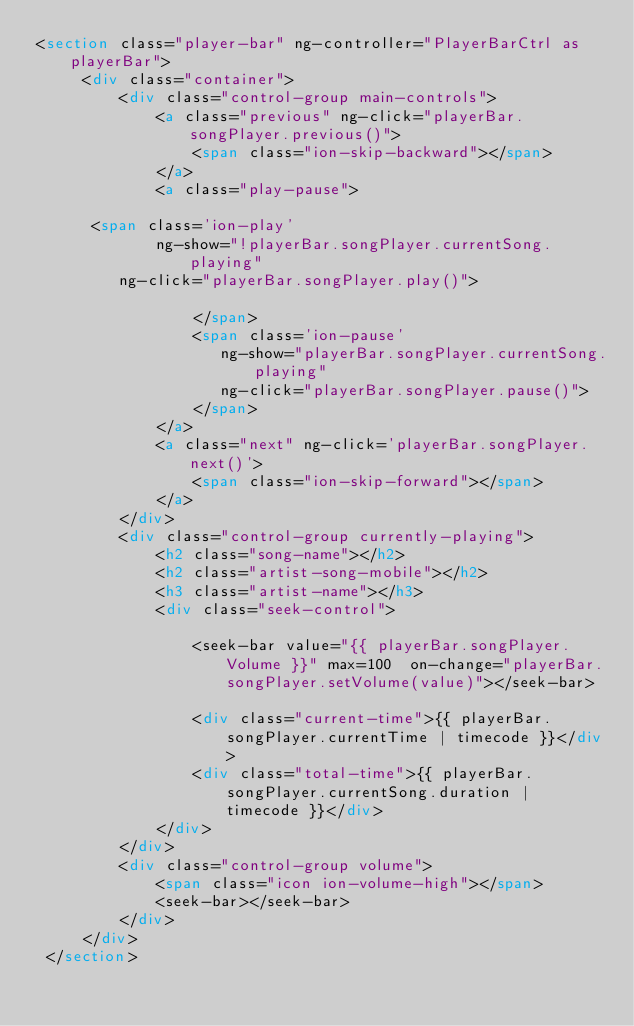<code> <loc_0><loc_0><loc_500><loc_500><_HTML_><section class="player-bar" ng-controller="PlayerBarCtrl as playerBar">
     <div class="container">
         <div class="control-group main-controls">
             <a class="previous" ng-click="playerBar.songPlayer.previous()">
                 <span class="ion-skip-backward"></span>
             </a>
             <a class="play-pause">
                 
      <span class='ion-play'
             ng-show="!playerBar.songPlayer.currentSong.playing"
         ng-click="playerBar.songPlayer.play()">
       
                 </span>
                 <span class='ion-pause'
                    ng-show="playerBar.songPlayer.currentSong.playing"
                    ng-click="playerBar.songPlayer.pause()">
                 </span>
             </a>
             <a class="next" ng-click='playerBar.songPlayer.next()'>
                 <span class="ion-skip-forward"></span>
             </a>
         </div>
         <div class="control-group currently-playing">
             <h2 class="song-name"></h2>
             <h2 class="artist-song-mobile"></h2>
             <h3 class="artist-name"></h3>
             <div class="seek-control">
               
                 <seek-bar value="{{ playerBar.songPlayer.Volume }}" max=100  on-change="playerBar.songPlayer.setVolume(value)"></seek-bar>
                 
                 <div class="current-time">{{ playerBar.songPlayer.currentTime | timecode }}</div>
                 <div class="total-time">{{ playerBar.songPlayer.currentSong.duration | timecode }}</div>
             </div>
         </div>
         <div class="control-group volume">
             <span class="icon ion-volume-high"></span>
             <seek-bar></seek-bar>
         </div>
     </div>
 </section></code> 